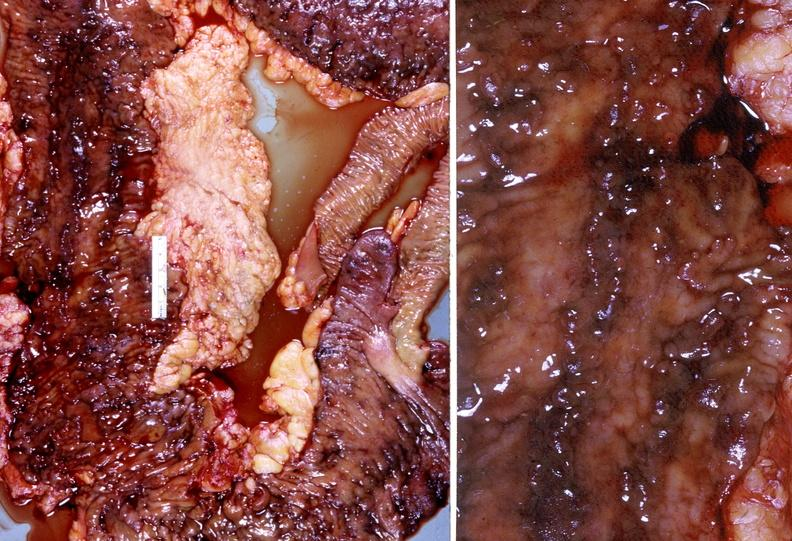where does this belong to?
Answer the question using a single word or phrase. Gastrointestinal system 